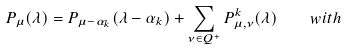<formula> <loc_0><loc_0><loc_500><loc_500>P _ { \mu } ( \lambda ) = P _ { \mu - \alpha _ { k } } ( \lambda - \alpha _ { k } ) + \sum _ { \nu \in Q ^ { + } } P _ { \mu , \nu } ^ { k } ( \lambda ) \quad w i t h</formula> 